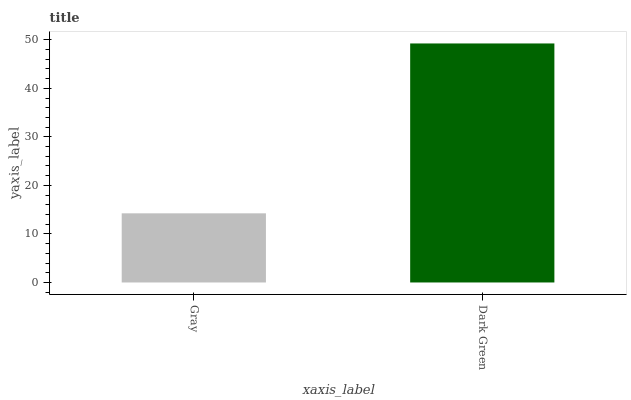Is Gray the minimum?
Answer yes or no. Yes. Is Dark Green the maximum?
Answer yes or no. Yes. Is Dark Green the minimum?
Answer yes or no. No. Is Dark Green greater than Gray?
Answer yes or no. Yes. Is Gray less than Dark Green?
Answer yes or no. Yes. Is Gray greater than Dark Green?
Answer yes or no. No. Is Dark Green less than Gray?
Answer yes or no. No. Is Dark Green the high median?
Answer yes or no. Yes. Is Gray the low median?
Answer yes or no. Yes. Is Gray the high median?
Answer yes or no. No. Is Dark Green the low median?
Answer yes or no. No. 